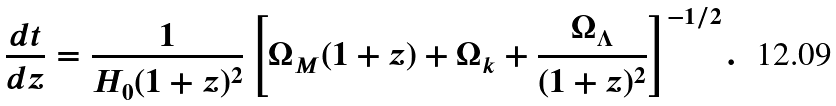Convert formula to latex. <formula><loc_0><loc_0><loc_500><loc_500>\frac { d t } { d z } = \frac { 1 } { H _ { 0 } ( 1 + z ) ^ { 2 } } \left [ \Omega _ { M } ( 1 + z ) + \Omega _ { k } + \frac { \Omega _ { \Lambda } } { ( 1 + z ) ^ { 2 } } \right ] ^ { - 1 / 2 } .</formula> 